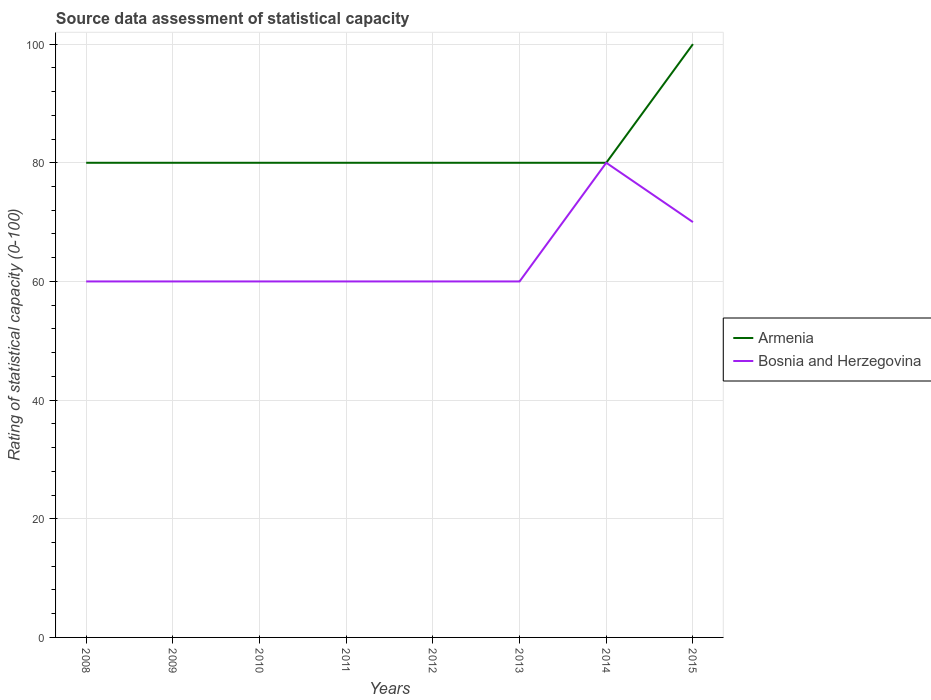Is the number of lines equal to the number of legend labels?
Provide a short and direct response. Yes. Across all years, what is the maximum rating of statistical capacity in Armenia?
Ensure brevity in your answer.  80. In which year was the rating of statistical capacity in Bosnia and Herzegovina maximum?
Give a very brief answer. 2008. What is the total rating of statistical capacity in Armenia in the graph?
Give a very brief answer. 0. What is the difference between the highest and the second highest rating of statistical capacity in Armenia?
Make the answer very short. 20. What is the difference between the highest and the lowest rating of statistical capacity in Bosnia and Herzegovina?
Provide a short and direct response. 2. Is the rating of statistical capacity in Bosnia and Herzegovina strictly greater than the rating of statistical capacity in Armenia over the years?
Your answer should be very brief. No. How many years are there in the graph?
Offer a very short reply. 8. What is the difference between two consecutive major ticks on the Y-axis?
Your answer should be compact. 20. Are the values on the major ticks of Y-axis written in scientific E-notation?
Offer a terse response. No. What is the title of the graph?
Keep it short and to the point. Source data assessment of statistical capacity. What is the label or title of the X-axis?
Keep it short and to the point. Years. What is the label or title of the Y-axis?
Give a very brief answer. Rating of statistical capacity (0-100). What is the Rating of statistical capacity (0-100) of Armenia in 2008?
Provide a short and direct response. 80. What is the Rating of statistical capacity (0-100) of Armenia in 2009?
Offer a very short reply. 80. What is the Rating of statistical capacity (0-100) in Armenia in 2010?
Your response must be concise. 80. What is the Rating of statistical capacity (0-100) of Armenia in 2012?
Your answer should be compact. 80. What is the Rating of statistical capacity (0-100) in Bosnia and Herzegovina in 2013?
Provide a short and direct response. 60. What is the Rating of statistical capacity (0-100) of Armenia in 2014?
Provide a short and direct response. 80. What is the Rating of statistical capacity (0-100) of Bosnia and Herzegovina in 2014?
Make the answer very short. 80. What is the Rating of statistical capacity (0-100) in Armenia in 2015?
Provide a succinct answer. 100. What is the Rating of statistical capacity (0-100) in Bosnia and Herzegovina in 2015?
Ensure brevity in your answer.  70. Across all years, what is the maximum Rating of statistical capacity (0-100) of Armenia?
Your answer should be compact. 100. Across all years, what is the maximum Rating of statistical capacity (0-100) of Bosnia and Herzegovina?
Make the answer very short. 80. Across all years, what is the minimum Rating of statistical capacity (0-100) in Bosnia and Herzegovina?
Your response must be concise. 60. What is the total Rating of statistical capacity (0-100) in Armenia in the graph?
Give a very brief answer. 660. What is the total Rating of statistical capacity (0-100) in Bosnia and Herzegovina in the graph?
Your answer should be very brief. 510. What is the difference between the Rating of statistical capacity (0-100) of Armenia in 2008 and that in 2009?
Keep it short and to the point. 0. What is the difference between the Rating of statistical capacity (0-100) in Armenia in 2008 and that in 2010?
Your response must be concise. 0. What is the difference between the Rating of statistical capacity (0-100) of Bosnia and Herzegovina in 2008 and that in 2010?
Offer a very short reply. 0. What is the difference between the Rating of statistical capacity (0-100) in Armenia in 2008 and that in 2011?
Your response must be concise. 0. What is the difference between the Rating of statistical capacity (0-100) in Armenia in 2008 and that in 2013?
Offer a terse response. 0. What is the difference between the Rating of statistical capacity (0-100) of Bosnia and Herzegovina in 2008 and that in 2013?
Provide a short and direct response. 0. What is the difference between the Rating of statistical capacity (0-100) in Armenia in 2008 and that in 2014?
Give a very brief answer. 0. What is the difference between the Rating of statistical capacity (0-100) of Armenia in 2009 and that in 2010?
Give a very brief answer. 0. What is the difference between the Rating of statistical capacity (0-100) of Bosnia and Herzegovina in 2009 and that in 2011?
Your response must be concise. 0. What is the difference between the Rating of statistical capacity (0-100) of Armenia in 2009 and that in 2013?
Offer a terse response. 0. What is the difference between the Rating of statistical capacity (0-100) of Armenia in 2009 and that in 2014?
Give a very brief answer. 0. What is the difference between the Rating of statistical capacity (0-100) in Armenia in 2009 and that in 2015?
Provide a succinct answer. -20. What is the difference between the Rating of statistical capacity (0-100) in Bosnia and Herzegovina in 2009 and that in 2015?
Your answer should be compact. -10. What is the difference between the Rating of statistical capacity (0-100) of Armenia in 2010 and that in 2012?
Your answer should be very brief. 0. What is the difference between the Rating of statistical capacity (0-100) of Bosnia and Herzegovina in 2010 and that in 2013?
Keep it short and to the point. 0. What is the difference between the Rating of statistical capacity (0-100) in Bosnia and Herzegovina in 2010 and that in 2014?
Ensure brevity in your answer.  -20. What is the difference between the Rating of statistical capacity (0-100) of Armenia in 2010 and that in 2015?
Provide a short and direct response. -20. What is the difference between the Rating of statistical capacity (0-100) in Bosnia and Herzegovina in 2010 and that in 2015?
Provide a short and direct response. -10. What is the difference between the Rating of statistical capacity (0-100) of Bosnia and Herzegovina in 2011 and that in 2012?
Provide a succinct answer. 0. What is the difference between the Rating of statistical capacity (0-100) of Armenia in 2011 and that in 2013?
Ensure brevity in your answer.  0. What is the difference between the Rating of statistical capacity (0-100) of Bosnia and Herzegovina in 2011 and that in 2013?
Offer a terse response. 0. What is the difference between the Rating of statistical capacity (0-100) of Armenia in 2011 and that in 2014?
Your response must be concise. 0. What is the difference between the Rating of statistical capacity (0-100) in Bosnia and Herzegovina in 2011 and that in 2014?
Provide a short and direct response. -20. What is the difference between the Rating of statistical capacity (0-100) in Bosnia and Herzegovina in 2011 and that in 2015?
Your answer should be compact. -10. What is the difference between the Rating of statistical capacity (0-100) in Armenia in 2012 and that in 2013?
Your answer should be compact. 0. What is the difference between the Rating of statistical capacity (0-100) of Bosnia and Herzegovina in 2012 and that in 2013?
Make the answer very short. 0. What is the difference between the Rating of statistical capacity (0-100) of Armenia in 2012 and that in 2014?
Keep it short and to the point. 0. What is the difference between the Rating of statistical capacity (0-100) in Armenia in 2012 and that in 2015?
Offer a terse response. -20. What is the difference between the Rating of statistical capacity (0-100) of Armenia in 2013 and that in 2014?
Your answer should be compact. 0. What is the difference between the Rating of statistical capacity (0-100) in Armenia in 2013 and that in 2015?
Give a very brief answer. -20. What is the difference between the Rating of statistical capacity (0-100) in Bosnia and Herzegovina in 2013 and that in 2015?
Provide a short and direct response. -10. What is the difference between the Rating of statistical capacity (0-100) of Armenia in 2014 and that in 2015?
Offer a very short reply. -20. What is the difference between the Rating of statistical capacity (0-100) in Armenia in 2008 and the Rating of statistical capacity (0-100) in Bosnia and Herzegovina in 2011?
Your answer should be very brief. 20. What is the difference between the Rating of statistical capacity (0-100) in Armenia in 2008 and the Rating of statistical capacity (0-100) in Bosnia and Herzegovina in 2013?
Provide a succinct answer. 20. What is the difference between the Rating of statistical capacity (0-100) of Armenia in 2009 and the Rating of statistical capacity (0-100) of Bosnia and Herzegovina in 2014?
Ensure brevity in your answer.  0. What is the difference between the Rating of statistical capacity (0-100) in Armenia in 2009 and the Rating of statistical capacity (0-100) in Bosnia and Herzegovina in 2015?
Offer a terse response. 10. What is the difference between the Rating of statistical capacity (0-100) in Armenia in 2010 and the Rating of statistical capacity (0-100) in Bosnia and Herzegovina in 2011?
Your answer should be very brief. 20. What is the difference between the Rating of statistical capacity (0-100) in Armenia in 2011 and the Rating of statistical capacity (0-100) in Bosnia and Herzegovina in 2012?
Offer a terse response. 20. What is the difference between the Rating of statistical capacity (0-100) in Armenia in 2011 and the Rating of statistical capacity (0-100) in Bosnia and Herzegovina in 2014?
Provide a succinct answer. 0. What is the difference between the Rating of statistical capacity (0-100) of Armenia in 2011 and the Rating of statistical capacity (0-100) of Bosnia and Herzegovina in 2015?
Your answer should be compact. 10. What is the difference between the Rating of statistical capacity (0-100) in Armenia in 2012 and the Rating of statistical capacity (0-100) in Bosnia and Herzegovina in 2013?
Ensure brevity in your answer.  20. What is the difference between the Rating of statistical capacity (0-100) in Armenia in 2012 and the Rating of statistical capacity (0-100) in Bosnia and Herzegovina in 2014?
Your response must be concise. 0. What is the difference between the Rating of statistical capacity (0-100) of Armenia in 2013 and the Rating of statistical capacity (0-100) of Bosnia and Herzegovina in 2014?
Your answer should be compact. 0. What is the average Rating of statistical capacity (0-100) in Armenia per year?
Offer a very short reply. 82.5. What is the average Rating of statistical capacity (0-100) of Bosnia and Herzegovina per year?
Make the answer very short. 63.75. In the year 2008, what is the difference between the Rating of statistical capacity (0-100) of Armenia and Rating of statistical capacity (0-100) of Bosnia and Herzegovina?
Make the answer very short. 20. In the year 2009, what is the difference between the Rating of statistical capacity (0-100) of Armenia and Rating of statistical capacity (0-100) of Bosnia and Herzegovina?
Keep it short and to the point. 20. In the year 2012, what is the difference between the Rating of statistical capacity (0-100) in Armenia and Rating of statistical capacity (0-100) in Bosnia and Herzegovina?
Your answer should be very brief. 20. In the year 2015, what is the difference between the Rating of statistical capacity (0-100) in Armenia and Rating of statistical capacity (0-100) in Bosnia and Herzegovina?
Ensure brevity in your answer.  30. What is the ratio of the Rating of statistical capacity (0-100) in Armenia in 2008 to that in 2009?
Keep it short and to the point. 1. What is the ratio of the Rating of statistical capacity (0-100) of Armenia in 2008 to that in 2010?
Your answer should be very brief. 1. What is the ratio of the Rating of statistical capacity (0-100) of Armenia in 2008 to that in 2011?
Your answer should be very brief. 1. What is the ratio of the Rating of statistical capacity (0-100) in Armenia in 2008 to that in 2014?
Provide a succinct answer. 1. What is the ratio of the Rating of statistical capacity (0-100) in Armenia in 2008 to that in 2015?
Give a very brief answer. 0.8. What is the ratio of the Rating of statistical capacity (0-100) in Armenia in 2009 to that in 2010?
Make the answer very short. 1. What is the ratio of the Rating of statistical capacity (0-100) in Bosnia and Herzegovina in 2009 to that in 2010?
Your answer should be compact. 1. What is the ratio of the Rating of statistical capacity (0-100) in Armenia in 2009 to that in 2011?
Offer a terse response. 1. What is the ratio of the Rating of statistical capacity (0-100) in Armenia in 2009 to that in 2013?
Your answer should be compact. 1. What is the ratio of the Rating of statistical capacity (0-100) in Bosnia and Herzegovina in 2009 to that in 2013?
Your answer should be compact. 1. What is the ratio of the Rating of statistical capacity (0-100) in Armenia in 2009 to that in 2014?
Offer a very short reply. 1. What is the ratio of the Rating of statistical capacity (0-100) of Bosnia and Herzegovina in 2009 to that in 2015?
Provide a succinct answer. 0.86. What is the ratio of the Rating of statistical capacity (0-100) in Armenia in 2010 to that in 2011?
Your answer should be very brief. 1. What is the ratio of the Rating of statistical capacity (0-100) of Armenia in 2010 to that in 2013?
Give a very brief answer. 1. What is the ratio of the Rating of statistical capacity (0-100) in Bosnia and Herzegovina in 2010 to that in 2013?
Give a very brief answer. 1. What is the ratio of the Rating of statistical capacity (0-100) in Armenia in 2010 to that in 2015?
Keep it short and to the point. 0.8. What is the ratio of the Rating of statistical capacity (0-100) of Bosnia and Herzegovina in 2010 to that in 2015?
Offer a very short reply. 0.86. What is the ratio of the Rating of statistical capacity (0-100) of Bosnia and Herzegovina in 2011 to that in 2012?
Provide a succinct answer. 1. What is the ratio of the Rating of statistical capacity (0-100) in Armenia in 2011 to that in 2013?
Offer a very short reply. 1. What is the ratio of the Rating of statistical capacity (0-100) in Bosnia and Herzegovina in 2011 to that in 2013?
Your response must be concise. 1. What is the ratio of the Rating of statistical capacity (0-100) in Armenia in 2012 to that in 2013?
Ensure brevity in your answer.  1. What is the ratio of the Rating of statistical capacity (0-100) in Armenia in 2012 to that in 2014?
Your response must be concise. 1. What is the ratio of the Rating of statistical capacity (0-100) in Bosnia and Herzegovina in 2012 to that in 2014?
Your answer should be compact. 0.75. What is the ratio of the Rating of statistical capacity (0-100) of Armenia in 2013 to that in 2014?
Offer a very short reply. 1. What is the ratio of the Rating of statistical capacity (0-100) of Bosnia and Herzegovina in 2013 to that in 2014?
Your response must be concise. 0.75. What is the ratio of the Rating of statistical capacity (0-100) in Bosnia and Herzegovina in 2014 to that in 2015?
Your answer should be compact. 1.14. What is the difference between the highest and the second highest Rating of statistical capacity (0-100) of Armenia?
Provide a succinct answer. 20. What is the difference between the highest and the lowest Rating of statistical capacity (0-100) in Armenia?
Provide a short and direct response. 20. 